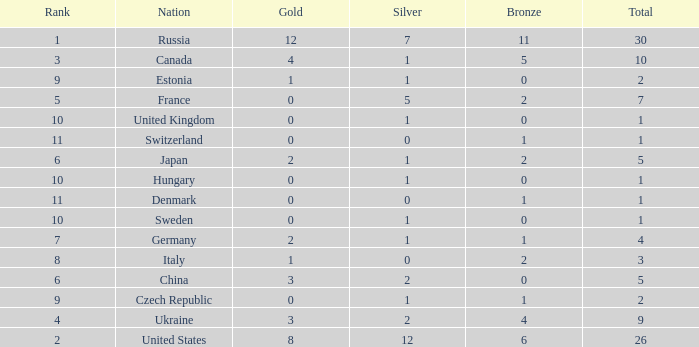Which silver has a Gold smaller than 12, a Rank smaller than 5, and a Bronze of 5? 1.0. 